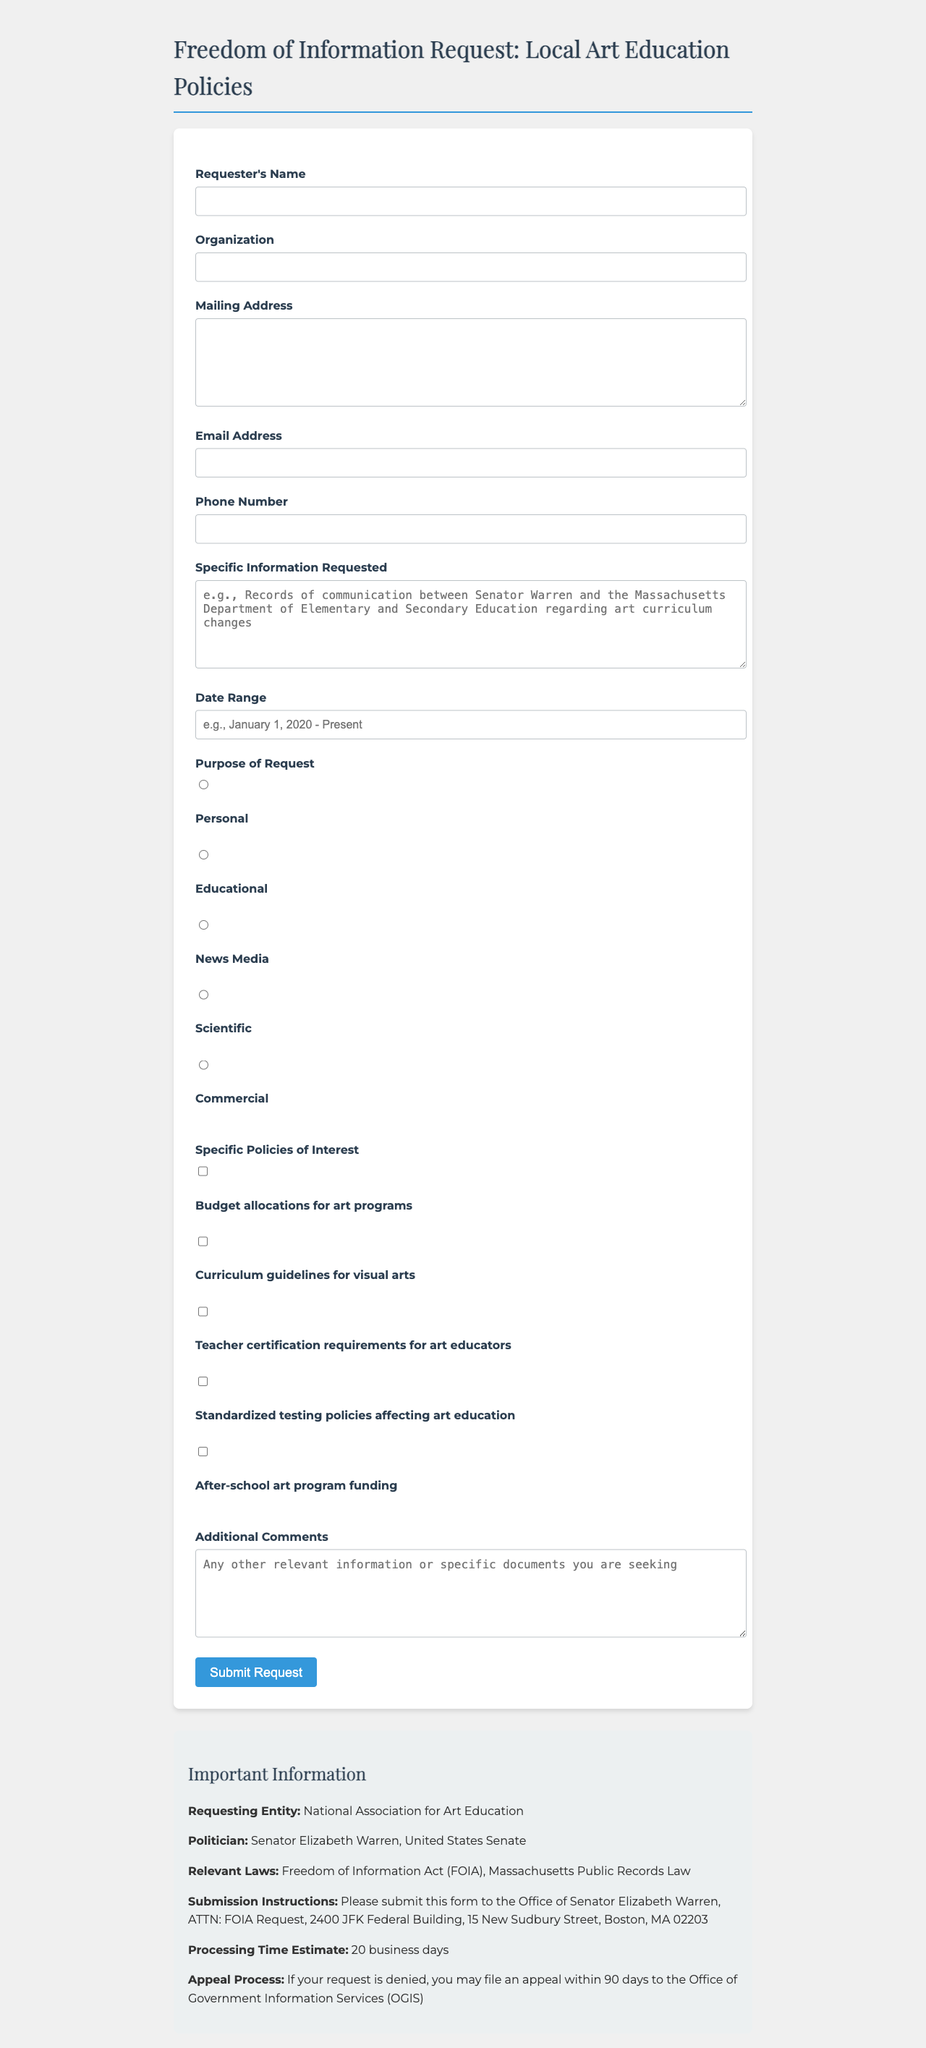What is the title of the form? The title represents the main subject of the document, indicating it's a request for information related to local art education policies.
Answer: Freedom of Information Request: Local Art Education Policies Who is the requesting entity? The requesting entity is the organization or individual seeking information under the Freedom of Information Act.
Answer: National Association for Art Education What is the estimated processing time? This is the timeframe provided for how long it will take to process the request once submitted.
Answer: 20 business days What is the purpose of the request? This pertains to the category that the requester must choose for their inquiry and has various options provided.
Answer: News Media What specific information is requested? The requester specifies the exact information they wish to obtain, which can include records of communication or policy details.
Answer: Records of communication between Senator Warren and the Massachusetts Department of Elementary and Secondary Education regarding art curriculum changes Which laws are relevant to the request? These laws provide the legislative framework under which the freedom of information request is made.
Answer: Freedom of Information Act (FOIA), Massachusetts Public Records Law 